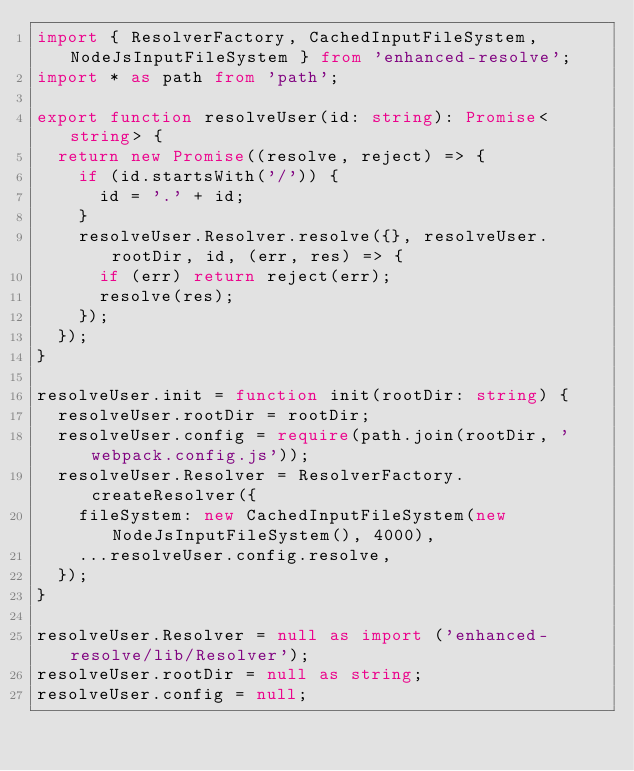<code> <loc_0><loc_0><loc_500><loc_500><_TypeScript_>import { ResolverFactory, CachedInputFileSystem, NodeJsInputFileSystem } from 'enhanced-resolve';
import * as path from 'path';

export function resolveUser(id: string): Promise<string> {
  return new Promise((resolve, reject) => {
    if (id.startsWith('/')) {
      id = '.' + id;
    }
    resolveUser.Resolver.resolve({}, resolveUser.rootDir, id, (err, res) => {
      if (err) return reject(err);
      resolve(res);
    });
  });
}

resolveUser.init = function init(rootDir: string) {
  resolveUser.rootDir = rootDir;
  resolveUser.config = require(path.join(rootDir, 'webpack.config.js'));
  resolveUser.Resolver = ResolverFactory.createResolver({
    fileSystem: new CachedInputFileSystem(new NodeJsInputFileSystem(), 4000),
    ...resolveUser.config.resolve,
  });
}

resolveUser.Resolver = null as import ('enhanced-resolve/lib/Resolver');
resolveUser.rootDir = null as string;
resolveUser.config = null;
</code> 